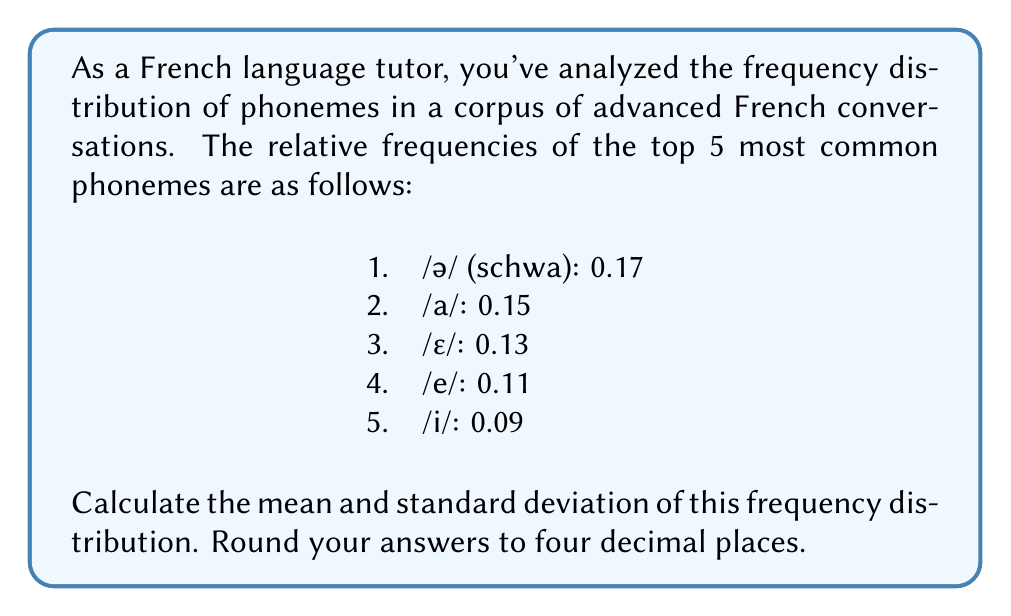Give your solution to this math problem. To solve this problem, we'll follow these steps:

1. Calculate the mean (μ)
2. Calculate the variance (σ²)
3. Calculate the standard deviation (σ)

Step 1: Calculate the mean (μ)
The mean is the sum of all values divided by the number of values.

$$ \mu = \frac{\sum_{i=1}^{n} x_i}{n} $$

$$ \mu = \frac{0.17 + 0.15 + 0.13 + 0.11 + 0.09}{5} = \frac{0.65}{5} = 0.13 $$

Step 2: Calculate the variance (σ²)
The variance is the average of the squared differences from the mean.

$$ \sigma^2 = \frac{\sum_{i=1}^{n} (x_i - \mu)^2}{n} $$

$$ \sigma^2 = \frac{(0.17 - 0.13)^2 + (0.15 - 0.13)^2 + (0.13 - 0.13)^2 + (0.11 - 0.13)^2 + (0.09 - 0.13)^2}{5} $$

$$ \sigma^2 = \frac{0.04^2 + 0.02^2 + 0^2 + (-0.02)^2 + (-0.04)^2}{5} $$

$$ \sigma^2 = \frac{0.0016 + 0.0004 + 0 + 0.0004 + 0.0016}{5} = \frac{0.004}{5} = 0.0008 $$

Step 3: Calculate the standard deviation (σ)
The standard deviation is the square root of the variance.

$$ \sigma = \sqrt{\sigma^2} = \sqrt{0.0008} \approx 0.0283 $$

Rounding to four decimal places:
Mean (μ) = 0.1300
Standard deviation (σ) = 0.0283
Answer: Mean: 0.1300, Standard deviation: 0.0283 